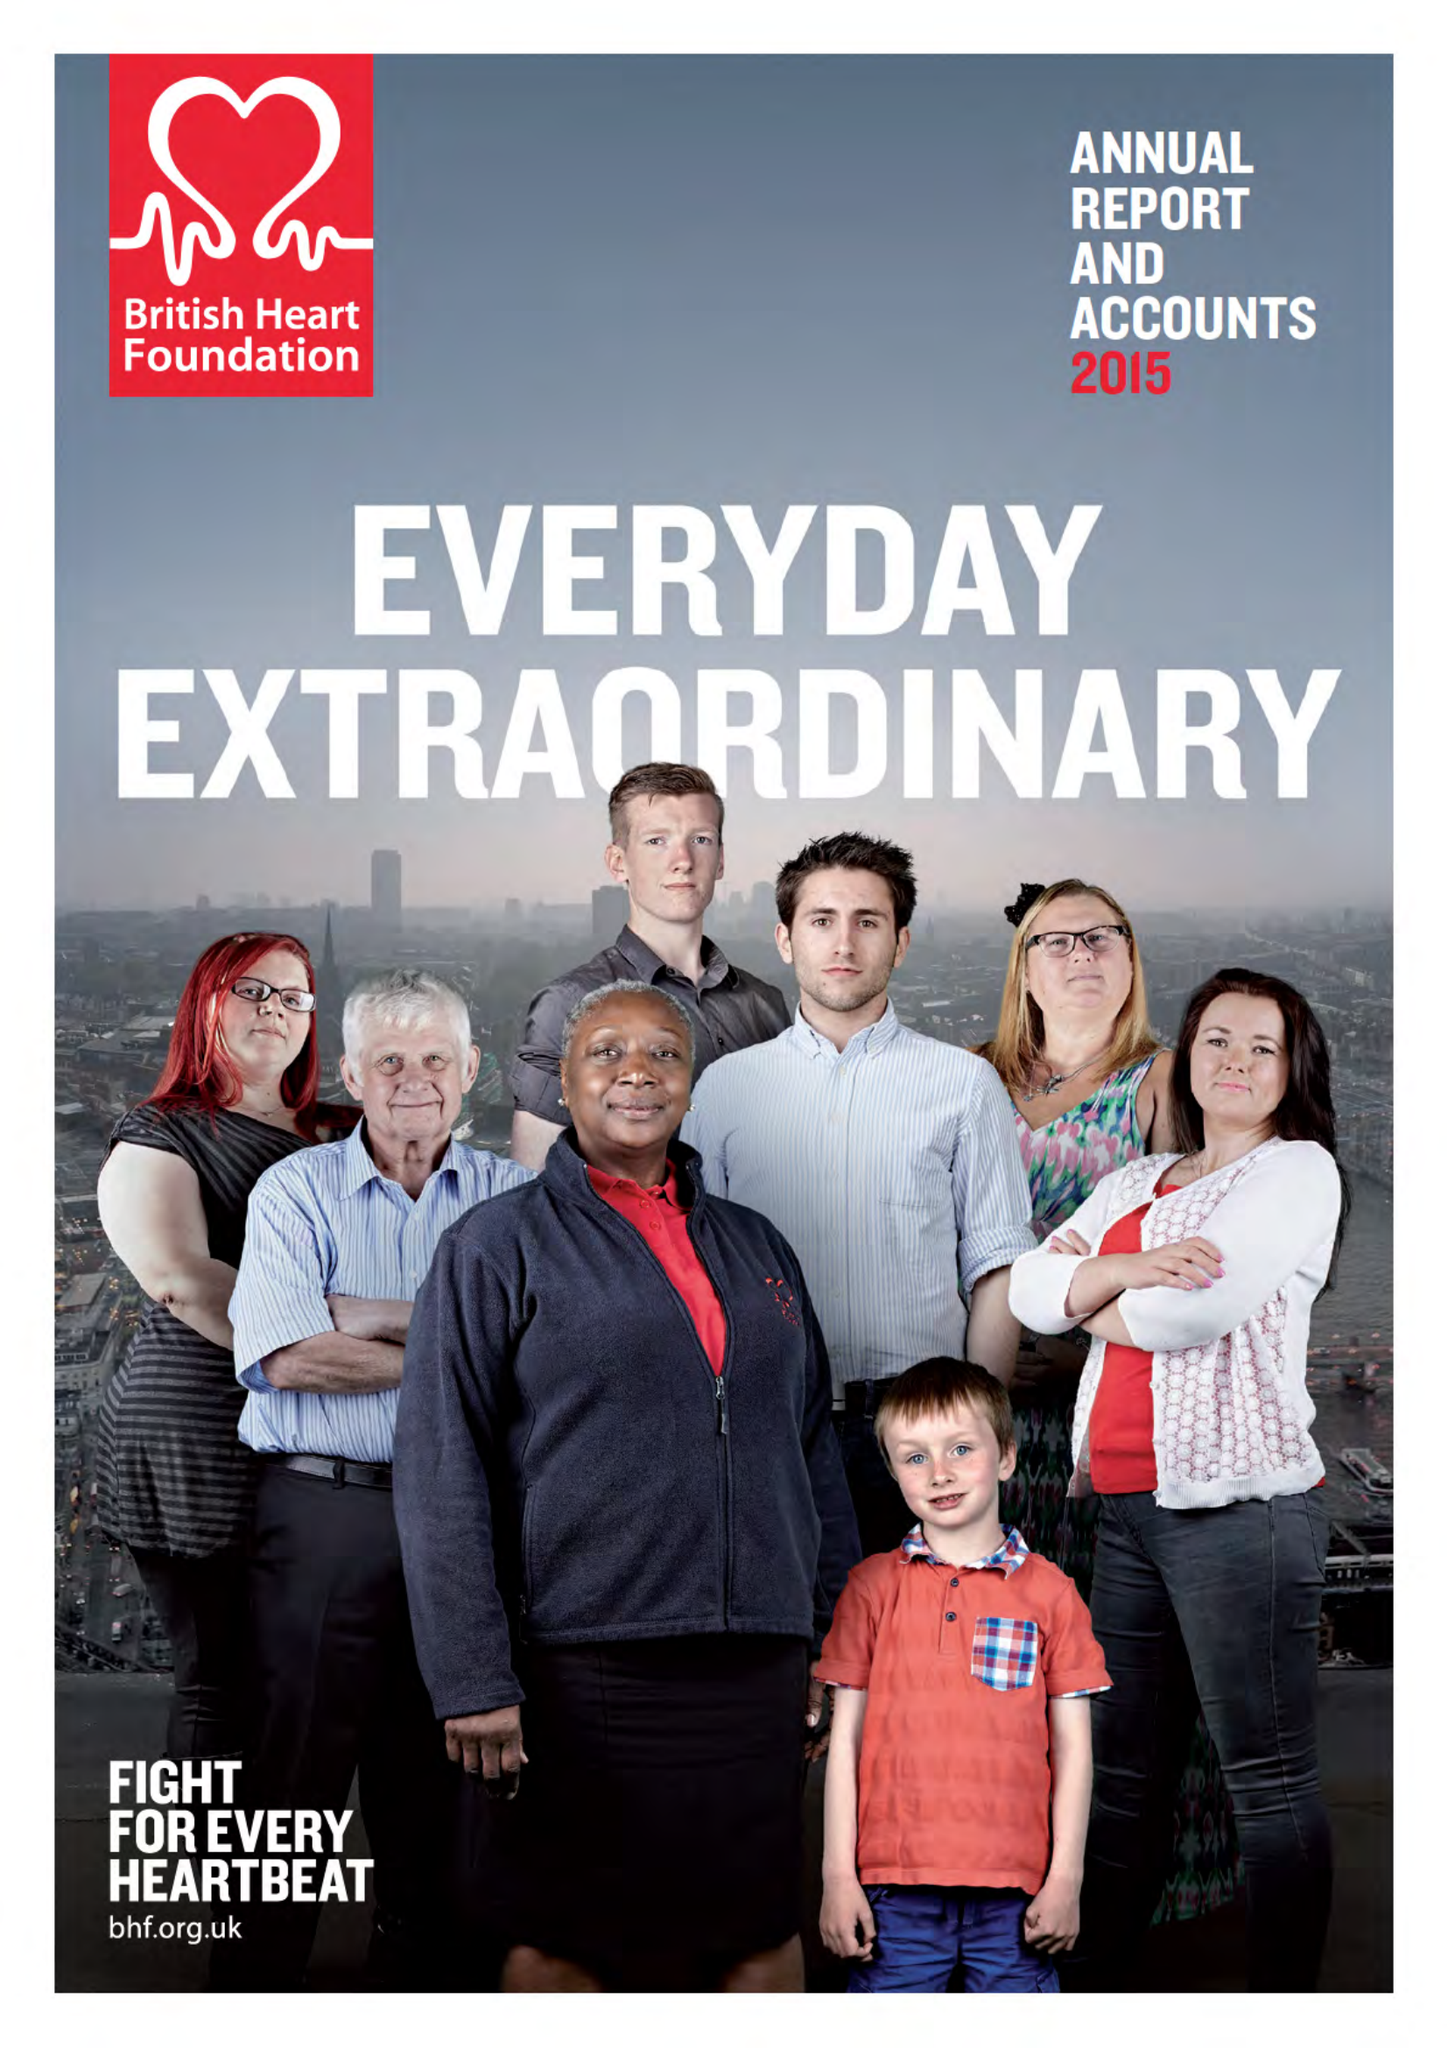What is the value for the income_annually_in_british_pounds?
Answer the question using a single word or phrase. 288200000.00 